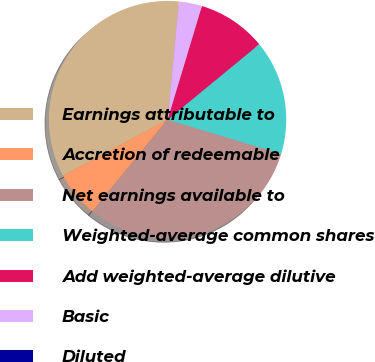Convert chart. <chart><loc_0><loc_0><loc_500><loc_500><pie_chart><fcel>Earnings attributable to<fcel>Accretion of redeemable<fcel>Net earnings available to<fcel>Weighted-average common shares<fcel>Add weighted-average dilutive<fcel>Basic<fcel>Diluted<nl><fcel>34.37%<fcel>6.25%<fcel>31.25%<fcel>15.63%<fcel>9.38%<fcel>3.13%<fcel>0.0%<nl></chart> 